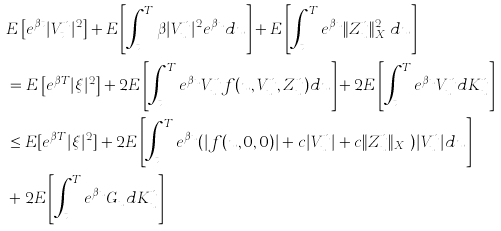Convert formula to latex. <formula><loc_0><loc_0><loc_500><loc_500>& E \left [ e ^ { \beta t } | V _ { t } ^ { n } | ^ { 2 } \right ] + E \left [ \int _ { t } ^ { T } \beta | V _ { u } ^ { n } | ^ { 2 } e ^ { \beta u } d u \right ] + E \left [ \int _ { t } ^ { T } e ^ { \beta u } \| Z _ { u } ^ { n } \| ^ { 2 } _ { X _ { u } } d u \right ] \\ & = E \left [ e ^ { \beta T } | \xi | ^ { 2 } \right ] + 2 E \left [ \int _ { t } ^ { T } e ^ { \beta u } V _ { u } ^ { n } f ( u , V _ { u } ^ { n } , Z _ { u } ^ { n } ) d u \right ] + 2 E \left [ \int _ { t } ^ { T } e ^ { \beta u } V _ { u } ^ { n } d K _ { u } ^ { n } \right ] \\ & \leq E [ e ^ { \beta T } | \xi | ^ { 2 } ] + 2 E \left [ \int _ { t } ^ { T } e ^ { \beta u } ( | f ( u , 0 , 0 ) | + c | V _ { u } ^ { n } | + c \| Z ^ { n } _ { u } \| _ { X _ { u } } ) | V _ { u } ^ { n } | d u \right ] \\ & + 2 E \left [ \int _ { t } ^ { T } e ^ { \beta u } G _ { u } d K _ { u } ^ { n } \right ]</formula> 